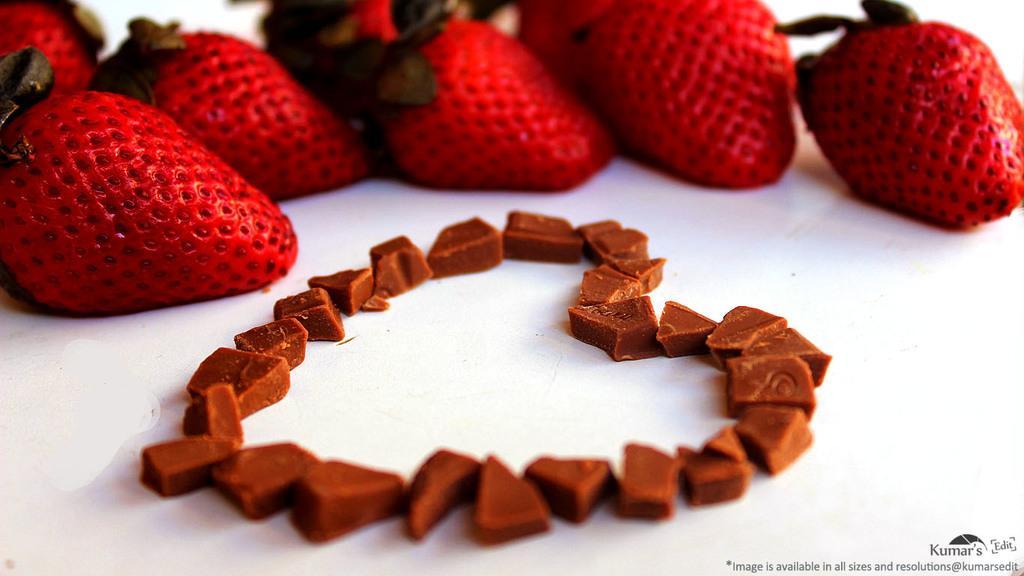How would you summarize this image in a sentence or two? In this image, we can see some red color strawberries and there are some brown color small pieces on the white color table. 